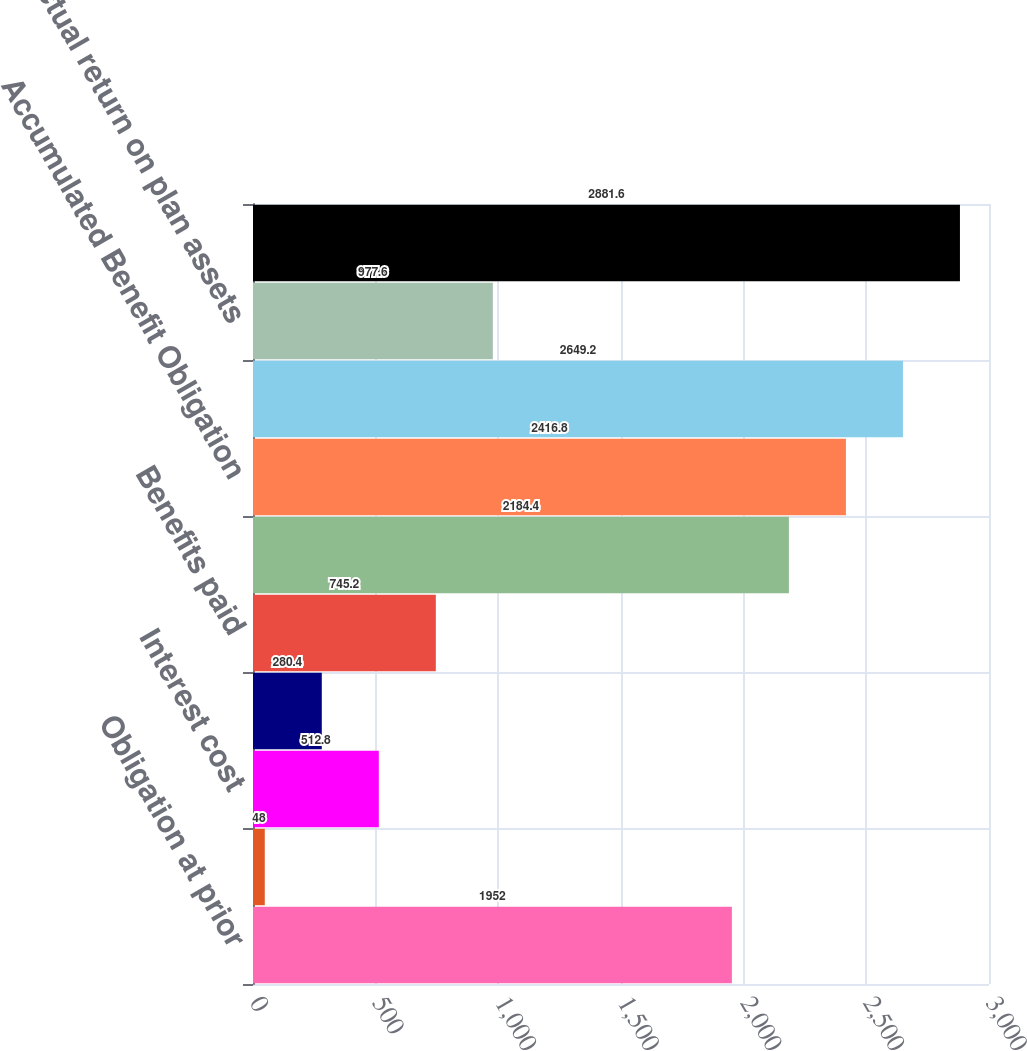Convert chart. <chart><loc_0><loc_0><loc_500><loc_500><bar_chart><fcel>Obligation at prior<fcel>Service cost<fcel>Interest cost<fcel>Actuarial loss<fcel>Benefits paid<fcel>Obligation at measurement date<fcel>Accumulated Benefit Obligation<fcel>Plan assets at prior<fcel>Actual return on plan assets<fcel>Plan assets at measurement<nl><fcel>1952<fcel>48<fcel>512.8<fcel>280.4<fcel>745.2<fcel>2184.4<fcel>2416.8<fcel>2649.2<fcel>977.6<fcel>2881.6<nl></chart> 